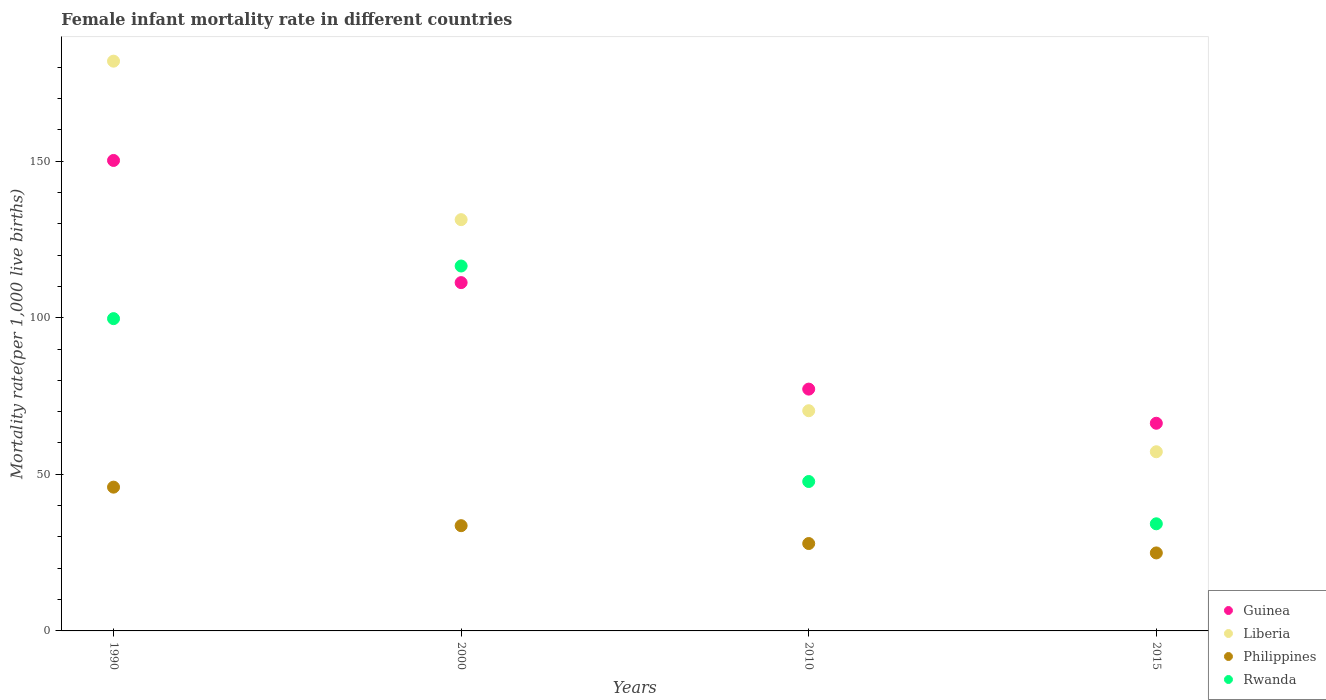What is the female infant mortality rate in Rwanda in 2015?
Your answer should be very brief. 34.2. Across all years, what is the maximum female infant mortality rate in Philippines?
Your answer should be compact. 45.9. Across all years, what is the minimum female infant mortality rate in Philippines?
Your response must be concise. 24.9. In which year was the female infant mortality rate in Rwanda maximum?
Offer a terse response. 2000. In which year was the female infant mortality rate in Philippines minimum?
Your answer should be compact. 2015. What is the total female infant mortality rate in Rwanda in the graph?
Your response must be concise. 298.1. What is the difference between the female infant mortality rate in Rwanda in 2010 and that in 2015?
Offer a terse response. 13.5. What is the difference between the female infant mortality rate in Liberia in 1990 and the female infant mortality rate in Rwanda in 2010?
Provide a succinct answer. 134.2. What is the average female infant mortality rate in Liberia per year?
Your answer should be compact. 110.18. In the year 2010, what is the difference between the female infant mortality rate in Guinea and female infant mortality rate in Philippines?
Ensure brevity in your answer.  49.3. In how many years, is the female infant mortality rate in Guinea greater than 150?
Keep it short and to the point. 1. What is the ratio of the female infant mortality rate in Liberia in 1990 to that in 2010?
Your response must be concise. 2.59. Is the female infant mortality rate in Guinea in 2000 less than that in 2010?
Make the answer very short. No. Is the difference between the female infant mortality rate in Guinea in 2000 and 2010 greater than the difference between the female infant mortality rate in Philippines in 2000 and 2010?
Make the answer very short. Yes. What is the difference between the highest and the second highest female infant mortality rate in Liberia?
Provide a short and direct response. 50.6. What is the difference between the highest and the lowest female infant mortality rate in Guinea?
Your answer should be compact. 83.9. Is it the case that in every year, the sum of the female infant mortality rate in Philippines and female infant mortality rate in Liberia  is greater than the female infant mortality rate in Guinea?
Keep it short and to the point. Yes. Does the female infant mortality rate in Rwanda monotonically increase over the years?
Offer a very short reply. No. Is the female infant mortality rate in Philippines strictly less than the female infant mortality rate in Rwanda over the years?
Provide a succinct answer. Yes. How many years are there in the graph?
Provide a short and direct response. 4. Are the values on the major ticks of Y-axis written in scientific E-notation?
Your answer should be very brief. No. Does the graph contain any zero values?
Make the answer very short. No. How are the legend labels stacked?
Your answer should be compact. Vertical. What is the title of the graph?
Your response must be concise. Female infant mortality rate in different countries. What is the label or title of the Y-axis?
Ensure brevity in your answer.  Mortality rate(per 1,0 live births). What is the Mortality rate(per 1,000 live births) of Guinea in 1990?
Your response must be concise. 150.2. What is the Mortality rate(per 1,000 live births) in Liberia in 1990?
Offer a terse response. 181.9. What is the Mortality rate(per 1,000 live births) of Philippines in 1990?
Offer a very short reply. 45.9. What is the Mortality rate(per 1,000 live births) of Rwanda in 1990?
Ensure brevity in your answer.  99.7. What is the Mortality rate(per 1,000 live births) in Guinea in 2000?
Provide a short and direct response. 111.2. What is the Mortality rate(per 1,000 live births) of Liberia in 2000?
Offer a terse response. 131.3. What is the Mortality rate(per 1,000 live births) of Philippines in 2000?
Offer a terse response. 33.6. What is the Mortality rate(per 1,000 live births) in Rwanda in 2000?
Keep it short and to the point. 116.5. What is the Mortality rate(per 1,000 live births) of Guinea in 2010?
Keep it short and to the point. 77.2. What is the Mortality rate(per 1,000 live births) of Liberia in 2010?
Offer a very short reply. 70.3. What is the Mortality rate(per 1,000 live births) in Philippines in 2010?
Offer a terse response. 27.9. What is the Mortality rate(per 1,000 live births) in Rwanda in 2010?
Keep it short and to the point. 47.7. What is the Mortality rate(per 1,000 live births) of Guinea in 2015?
Ensure brevity in your answer.  66.3. What is the Mortality rate(per 1,000 live births) of Liberia in 2015?
Give a very brief answer. 57.2. What is the Mortality rate(per 1,000 live births) in Philippines in 2015?
Ensure brevity in your answer.  24.9. What is the Mortality rate(per 1,000 live births) in Rwanda in 2015?
Make the answer very short. 34.2. Across all years, what is the maximum Mortality rate(per 1,000 live births) in Guinea?
Offer a terse response. 150.2. Across all years, what is the maximum Mortality rate(per 1,000 live births) of Liberia?
Offer a very short reply. 181.9. Across all years, what is the maximum Mortality rate(per 1,000 live births) of Philippines?
Your response must be concise. 45.9. Across all years, what is the maximum Mortality rate(per 1,000 live births) in Rwanda?
Your answer should be very brief. 116.5. Across all years, what is the minimum Mortality rate(per 1,000 live births) of Guinea?
Offer a terse response. 66.3. Across all years, what is the minimum Mortality rate(per 1,000 live births) in Liberia?
Give a very brief answer. 57.2. Across all years, what is the minimum Mortality rate(per 1,000 live births) in Philippines?
Ensure brevity in your answer.  24.9. Across all years, what is the minimum Mortality rate(per 1,000 live births) in Rwanda?
Your answer should be compact. 34.2. What is the total Mortality rate(per 1,000 live births) in Guinea in the graph?
Ensure brevity in your answer.  404.9. What is the total Mortality rate(per 1,000 live births) of Liberia in the graph?
Ensure brevity in your answer.  440.7. What is the total Mortality rate(per 1,000 live births) of Philippines in the graph?
Ensure brevity in your answer.  132.3. What is the total Mortality rate(per 1,000 live births) in Rwanda in the graph?
Your answer should be compact. 298.1. What is the difference between the Mortality rate(per 1,000 live births) of Guinea in 1990 and that in 2000?
Offer a very short reply. 39. What is the difference between the Mortality rate(per 1,000 live births) in Liberia in 1990 and that in 2000?
Keep it short and to the point. 50.6. What is the difference between the Mortality rate(per 1,000 live births) of Philippines in 1990 and that in 2000?
Make the answer very short. 12.3. What is the difference between the Mortality rate(per 1,000 live births) in Rwanda in 1990 and that in 2000?
Give a very brief answer. -16.8. What is the difference between the Mortality rate(per 1,000 live births) in Liberia in 1990 and that in 2010?
Your answer should be compact. 111.6. What is the difference between the Mortality rate(per 1,000 live births) in Rwanda in 1990 and that in 2010?
Give a very brief answer. 52. What is the difference between the Mortality rate(per 1,000 live births) in Guinea in 1990 and that in 2015?
Your response must be concise. 83.9. What is the difference between the Mortality rate(per 1,000 live births) of Liberia in 1990 and that in 2015?
Your answer should be very brief. 124.7. What is the difference between the Mortality rate(per 1,000 live births) of Philippines in 1990 and that in 2015?
Make the answer very short. 21. What is the difference between the Mortality rate(per 1,000 live births) of Rwanda in 1990 and that in 2015?
Offer a very short reply. 65.5. What is the difference between the Mortality rate(per 1,000 live births) in Guinea in 2000 and that in 2010?
Offer a terse response. 34. What is the difference between the Mortality rate(per 1,000 live births) in Philippines in 2000 and that in 2010?
Provide a short and direct response. 5.7. What is the difference between the Mortality rate(per 1,000 live births) of Rwanda in 2000 and that in 2010?
Make the answer very short. 68.8. What is the difference between the Mortality rate(per 1,000 live births) of Guinea in 2000 and that in 2015?
Your answer should be very brief. 44.9. What is the difference between the Mortality rate(per 1,000 live births) in Liberia in 2000 and that in 2015?
Provide a succinct answer. 74.1. What is the difference between the Mortality rate(per 1,000 live births) in Rwanda in 2000 and that in 2015?
Provide a succinct answer. 82.3. What is the difference between the Mortality rate(per 1,000 live births) in Liberia in 2010 and that in 2015?
Your answer should be compact. 13.1. What is the difference between the Mortality rate(per 1,000 live births) of Guinea in 1990 and the Mortality rate(per 1,000 live births) of Liberia in 2000?
Offer a terse response. 18.9. What is the difference between the Mortality rate(per 1,000 live births) of Guinea in 1990 and the Mortality rate(per 1,000 live births) of Philippines in 2000?
Your answer should be very brief. 116.6. What is the difference between the Mortality rate(per 1,000 live births) of Guinea in 1990 and the Mortality rate(per 1,000 live births) of Rwanda in 2000?
Keep it short and to the point. 33.7. What is the difference between the Mortality rate(per 1,000 live births) in Liberia in 1990 and the Mortality rate(per 1,000 live births) in Philippines in 2000?
Your response must be concise. 148.3. What is the difference between the Mortality rate(per 1,000 live births) of Liberia in 1990 and the Mortality rate(per 1,000 live births) of Rwanda in 2000?
Your answer should be compact. 65.4. What is the difference between the Mortality rate(per 1,000 live births) in Philippines in 1990 and the Mortality rate(per 1,000 live births) in Rwanda in 2000?
Provide a short and direct response. -70.6. What is the difference between the Mortality rate(per 1,000 live births) in Guinea in 1990 and the Mortality rate(per 1,000 live births) in Liberia in 2010?
Your answer should be very brief. 79.9. What is the difference between the Mortality rate(per 1,000 live births) of Guinea in 1990 and the Mortality rate(per 1,000 live births) of Philippines in 2010?
Give a very brief answer. 122.3. What is the difference between the Mortality rate(per 1,000 live births) of Guinea in 1990 and the Mortality rate(per 1,000 live births) of Rwanda in 2010?
Your answer should be very brief. 102.5. What is the difference between the Mortality rate(per 1,000 live births) of Liberia in 1990 and the Mortality rate(per 1,000 live births) of Philippines in 2010?
Offer a very short reply. 154. What is the difference between the Mortality rate(per 1,000 live births) in Liberia in 1990 and the Mortality rate(per 1,000 live births) in Rwanda in 2010?
Your response must be concise. 134.2. What is the difference between the Mortality rate(per 1,000 live births) of Guinea in 1990 and the Mortality rate(per 1,000 live births) of Liberia in 2015?
Make the answer very short. 93. What is the difference between the Mortality rate(per 1,000 live births) of Guinea in 1990 and the Mortality rate(per 1,000 live births) of Philippines in 2015?
Provide a succinct answer. 125.3. What is the difference between the Mortality rate(per 1,000 live births) of Guinea in 1990 and the Mortality rate(per 1,000 live births) of Rwanda in 2015?
Your answer should be very brief. 116. What is the difference between the Mortality rate(per 1,000 live births) in Liberia in 1990 and the Mortality rate(per 1,000 live births) in Philippines in 2015?
Provide a succinct answer. 157. What is the difference between the Mortality rate(per 1,000 live births) in Liberia in 1990 and the Mortality rate(per 1,000 live births) in Rwanda in 2015?
Offer a terse response. 147.7. What is the difference between the Mortality rate(per 1,000 live births) in Guinea in 2000 and the Mortality rate(per 1,000 live births) in Liberia in 2010?
Ensure brevity in your answer.  40.9. What is the difference between the Mortality rate(per 1,000 live births) in Guinea in 2000 and the Mortality rate(per 1,000 live births) in Philippines in 2010?
Provide a short and direct response. 83.3. What is the difference between the Mortality rate(per 1,000 live births) of Guinea in 2000 and the Mortality rate(per 1,000 live births) of Rwanda in 2010?
Make the answer very short. 63.5. What is the difference between the Mortality rate(per 1,000 live births) in Liberia in 2000 and the Mortality rate(per 1,000 live births) in Philippines in 2010?
Keep it short and to the point. 103.4. What is the difference between the Mortality rate(per 1,000 live births) of Liberia in 2000 and the Mortality rate(per 1,000 live births) of Rwanda in 2010?
Ensure brevity in your answer.  83.6. What is the difference between the Mortality rate(per 1,000 live births) of Philippines in 2000 and the Mortality rate(per 1,000 live births) of Rwanda in 2010?
Offer a terse response. -14.1. What is the difference between the Mortality rate(per 1,000 live births) of Guinea in 2000 and the Mortality rate(per 1,000 live births) of Philippines in 2015?
Your answer should be compact. 86.3. What is the difference between the Mortality rate(per 1,000 live births) of Guinea in 2000 and the Mortality rate(per 1,000 live births) of Rwanda in 2015?
Keep it short and to the point. 77. What is the difference between the Mortality rate(per 1,000 live births) of Liberia in 2000 and the Mortality rate(per 1,000 live births) of Philippines in 2015?
Your answer should be compact. 106.4. What is the difference between the Mortality rate(per 1,000 live births) in Liberia in 2000 and the Mortality rate(per 1,000 live births) in Rwanda in 2015?
Give a very brief answer. 97.1. What is the difference between the Mortality rate(per 1,000 live births) in Guinea in 2010 and the Mortality rate(per 1,000 live births) in Liberia in 2015?
Your response must be concise. 20. What is the difference between the Mortality rate(per 1,000 live births) in Guinea in 2010 and the Mortality rate(per 1,000 live births) in Philippines in 2015?
Give a very brief answer. 52.3. What is the difference between the Mortality rate(per 1,000 live births) in Guinea in 2010 and the Mortality rate(per 1,000 live births) in Rwanda in 2015?
Your answer should be very brief. 43. What is the difference between the Mortality rate(per 1,000 live births) of Liberia in 2010 and the Mortality rate(per 1,000 live births) of Philippines in 2015?
Your answer should be compact. 45.4. What is the difference between the Mortality rate(per 1,000 live births) of Liberia in 2010 and the Mortality rate(per 1,000 live births) of Rwanda in 2015?
Provide a short and direct response. 36.1. What is the difference between the Mortality rate(per 1,000 live births) in Philippines in 2010 and the Mortality rate(per 1,000 live births) in Rwanda in 2015?
Provide a short and direct response. -6.3. What is the average Mortality rate(per 1,000 live births) of Guinea per year?
Provide a short and direct response. 101.22. What is the average Mortality rate(per 1,000 live births) in Liberia per year?
Make the answer very short. 110.17. What is the average Mortality rate(per 1,000 live births) in Philippines per year?
Ensure brevity in your answer.  33.08. What is the average Mortality rate(per 1,000 live births) in Rwanda per year?
Give a very brief answer. 74.53. In the year 1990, what is the difference between the Mortality rate(per 1,000 live births) in Guinea and Mortality rate(per 1,000 live births) in Liberia?
Provide a short and direct response. -31.7. In the year 1990, what is the difference between the Mortality rate(per 1,000 live births) of Guinea and Mortality rate(per 1,000 live births) of Philippines?
Keep it short and to the point. 104.3. In the year 1990, what is the difference between the Mortality rate(per 1,000 live births) of Guinea and Mortality rate(per 1,000 live births) of Rwanda?
Your answer should be compact. 50.5. In the year 1990, what is the difference between the Mortality rate(per 1,000 live births) in Liberia and Mortality rate(per 1,000 live births) in Philippines?
Your answer should be very brief. 136. In the year 1990, what is the difference between the Mortality rate(per 1,000 live births) of Liberia and Mortality rate(per 1,000 live births) of Rwanda?
Ensure brevity in your answer.  82.2. In the year 1990, what is the difference between the Mortality rate(per 1,000 live births) of Philippines and Mortality rate(per 1,000 live births) of Rwanda?
Give a very brief answer. -53.8. In the year 2000, what is the difference between the Mortality rate(per 1,000 live births) of Guinea and Mortality rate(per 1,000 live births) of Liberia?
Ensure brevity in your answer.  -20.1. In the year 2000, what is the difference between the Mortality rate(per 1,000 live births) of Guinea and Mortality rate(per 1,000 live births) of Philippines?
Make the answer very short. 77.6. In the year 2000, what is the difference between the Mortality rate(per 1,000 live births) in Liberia and Mortality rate(per 1,000 live births) in Philippines?
Ensure brevity in your answer.  97.7. In the year 2000, what is the difference between the Mortality rate(per 1,000 live births) in Philippines and Mortality rate(per 1,000 live births) in Rwanda?
Your response must be concise. -82.9. In the year 2010, what is the difference between the Mortality rate(per 1,000 live births) of Guinea and Mortality rate(per 1,000 live births) of Philippines?
Give a very brief answer. 49.3. In the year 2010, what is the difference between the Mortality rate(per 1,000 live births) in Guinea and Mortality rate(per 1,000 live births) in Rwanda?
Ensure brevity in your answer.  29.5. In the year 2010, what is the difference between the Mortality rate(per 1,000 live births) of Liberia and Mortality rate(per 1,000 live births) of Philippines?
Your answer should be compact. 42.4. In the year 2010, what is the difference between the Mortality rate(per 1,000 live births) of Liberia and Mortality rate(per 1,000 live births) of Rwanda?
Keep it short and to the point. 22.6. In the year 2010, what is the difference between the Mortality rate(per 1,000 live births) of Philippines and Mortality rate(per 1,000 live births) of Rwanda?
Make the answer very short. -19.8. In the year 2015, what is the difference between the Mortality rate(per 1,000 live births) in Guinea and Mortality rate(per 1,000 live births) in Philippines?
Offer a terse response. 41.4. In the year 2015, what is the difference between the Mortality rate(per 1,000 live births) of Guinea and Mortality rate(per 1,000 live births) of Rwanda?
Ensure brevity in your answer.  32.1. In the year 2015, what is the difference between the Mortality rate(per 1,000 live births) in Liberia and Mortality rate(per 1,000 live births) in Philippines?
Your answer should be compact. 32.3. In the year 2015, what is the difference between the Mortality rate(per 1,000 live births) in Liberia and Mortality rate(per 1,000 live births) in Rwanda?
Ensure brevity in your answer.  23. What is the ratio of the Mortality rate(per 1,000 live births) of Guinea in 1990 to that in 2000?
Your answer should be very brief. 1.35. What is the ratio of the Mortality rate(per 1,000 live births) of Liberia in 1990 to that in 2000?
Make the answer very short. 1.39. What is the ratio of the Mortality rate(per 1,000 live births) of Philippines in 1990 to that in 2000?
Give a very brief answer. 1.37. What is the ratio of the Mortality rate(per 1,000 live births) in Rwanda in 1990 to that in 2000?
Make the answer very short. 0.86. What is the ratio of the Mortality rate(per 1,000 live births) in Guinea in 1990 to that in 2010?
Your answer should be very brief. 1.95. What is the ratio of the Mortality rate(per 1,000 live births) of Liberia in 1990 to that in 2010?
Offer a terse response. 2.59. What is the ratio of the Mortality rate(per 1,000 live births) of Philippines in 1990 to that in 2010?
Provide a succinct answer. 1.65. What is the ratio of the Mortality rate(per 1,000 live births) of Rwanda in 1990 to that in 2010?
Provide a succinct answer. 2.09. What is the ratio of the Mortality rate(per 1,000 live births) in Guinea in 1990 to that in 2015?
Your answer should be compact. 2.27. What is the ratio of the Mortality rate(per 1,000 live births) of Liberia in 1990 to that in 2015?
Keep it short and to the point. 3.18. What is the ratio of the Mortality rate(per 1,000 live births) of Philippines in 1990 to that in 2015?
Give a very brief answer. 1.84. What is the ratio of the Mortality rate(per 1,000 live births) in Rwanda in 1990 to that in 2015?
Your answer should be very brief. 2.92. What is the ratio of the Mortality rate(per 1,000 live births) of Guinea in 2000 to that in 2010?
Offer a very short reply. 1.44. What is the ratio of the Mortality rate(per 1,000 live births) in Liberia in 2000 to that in 2010?
Offer a very short reply. 1.87. What is the ratio of the Mortality rate(per 1,000 live births) of Philippines in 2000 to that in 2010?
Provide a succinct answer. 1.2. What is the ratio of the Mortality rate(per 1,000 live births) of Rwanda in 2000 to that in 2010?
Give a very brief answer. 2.44. What is the ratio of the Mortality rate(per 1,000 live births) in Guinea in 2000 to that in 2015?
Provide a succinct answer. 1.68. What is the ratio of the Mortality rate(per 1,000 live births) of Liberia in 2000 to that in 2015?
Offer a terse response. 2.3. What is the ratio of the Mortality rate(per 1,000 live births) in Philippines in 2000 to that in 2015?
Ensure brevity in your answer.  1.35. What is the ratio of the Mortality rate(per 1,000 live births) of Rwanda in 2000 to that in 2015?
Make the answer very short. 3.41. What is the ratio of the Mortality rate(per 1,000 live births) of Guinea in 2010 to that in 2015?
Keep it short and to the point. 1.16. What is the ratio of the Mortality rate(per 1,000 live births) in Liberia in 2010 to that in 2015?
Give a very brief answer. 1.23. What is the ratio of the Mortality rate(per 1,000 live births) of Philippines in 2010 to that in 2015?
Offer a very short reply. 1.12. What is the ratio of the Mortality rate(per 1,000 live births) in Rwanda in 2010 to that in 2015?
Offer a very short reply. 1.39. What is the difference between the highest and the second highest Mortality rate(per 1,000 live births) in Liberia?
Offer a very short reply. 50.6. What is the difference between the highest and the second highest Mortality rate(per 1,000 live births) in Philippines?
Offer a very short reply. 12.3. What is the difference between the highest and the lowest Mortality rate(per 1,000 live births) of Guinea?
Provide a succinct answer. 83.9. What is the difference between the highest and the lowest Mortality rate(per 1,000 live births) in Liberia?
Offer a terse response. 124.7. What is the difference between the highest and the lowest Mortality rate(per 1,000 live births) of Rwanda?
Provide a short and direct response. 82.3. 